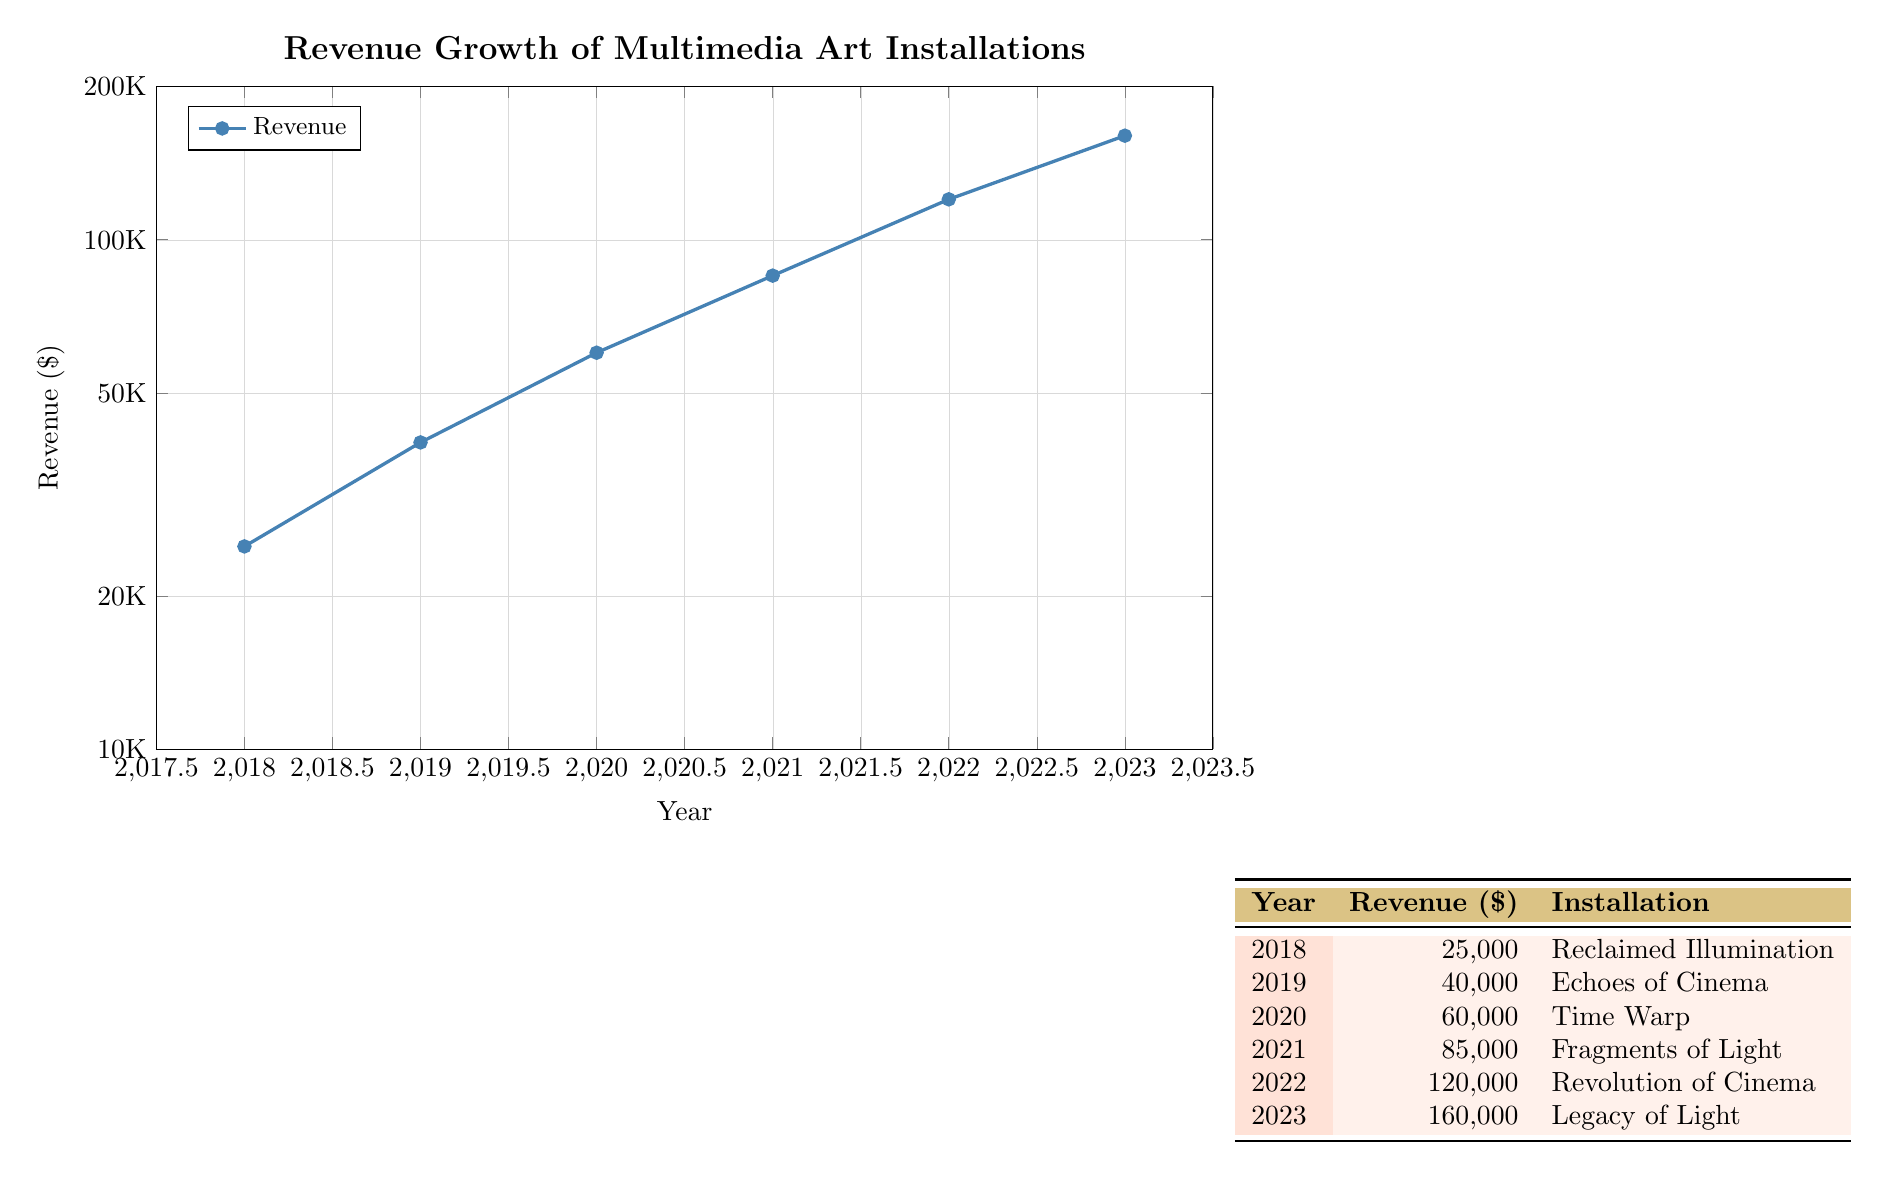What was the revenue for the installation "Time Warp" in 2020? The table shows that "Time Warp" was installed in 2020 and has a revenue listed as 60000.
Answer: 60000 What was the revenue growth from 2018 to 2022? In 2018, the revenue was 25000 and in 2022 it was 120000. To calculate the growth, we subtract 25000 from 120000 which is 120000 - 25000 = 95000.
Answer: 95000 Which installation had the highest revenue, and what year was it? The highest revenue recorded is 160000 for the installation "Legacy of Light," which was created in 2023.
Answer: "Legacy of Light," 2023 Is the revenue for the installation "Revolution of Cinema" greater than 100000? According to the table, "Revolution of Cinema" has a revenue of 120000, which is indeed greater than 100000.
Answer: Yes What was the average revenue of all installations from 2018 to 2023? To compute the average, first sum the revenues: 25000 + 40000 + 60000 + 85000 + 120000 + 160000 = 400000. There are 6 installations, so the average is 400000 divided by 6, which equals approximately 66666.67.
Answer: Approximately 66666.67 Was there a year when the revenue decreased compared to the previous year? For each year listed, the revenue was consistently increasing from year to year. Therefore, there was no year that showed a decrease compared to the previous year.
Answer: No How much more revenue did the installation "Legacy of Light" generate compared to "Reclaimed Illumination"? "Legacy of Light" generated 160000 and "Reclaimed Illumination" generated 25000. The difference is calculated by subtracting 25000 from 160000, which results in 160000 - 25000 = 135000.
Answer: 135000 What year saw a revenue of 85000, and which installation corresponds to this amount? The table lists the year 2021 with a revenue of 85000, corresponding to the installation called "Fragments of Light."
Answer: 2021, "Fragments of Light" 